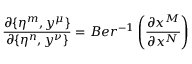Convert formula to latex. <formula><loc_0><loc_0><loc_500><loc_500>\frac { \partial \{ \eta ^ { m } , y ^ { \mu } \} } { \partial \{ \eta ^ { n } , y ^ { \nu } \} } = B e r ^ { - 1 } \left ( \frac { \partial x ^ { M } } { \partial x ^ { N } } \right )</formula> 